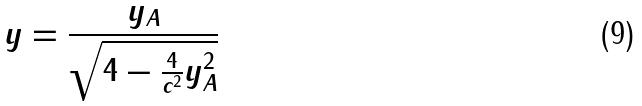<formula> <loc_0><loc_0><loc_500><loc_500>y = \frac { y _ { A } } { \sqrt { 4 - \frac { 4 } { c ^ { 2 } } y _ { A } ^ { 2 } } }</formula> 